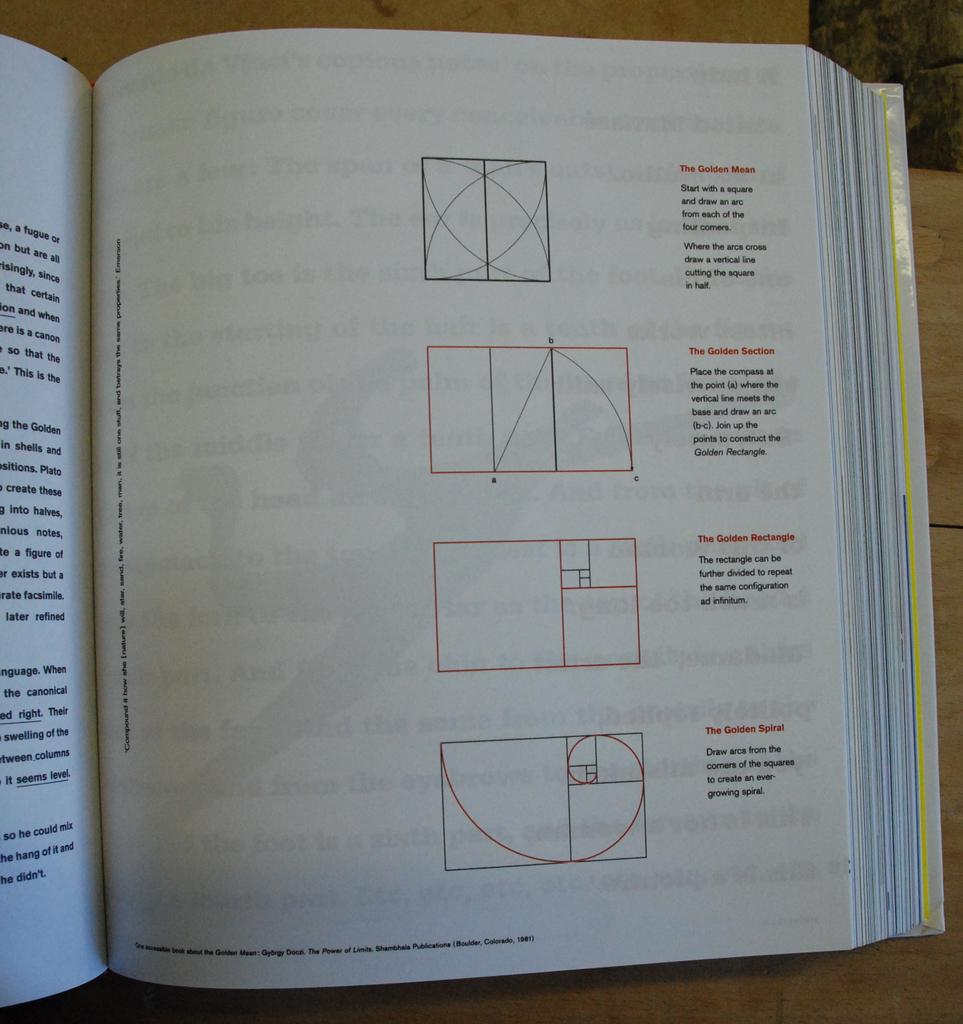<image>
Give a short and clear explanation of the subsequent image. A book showing several pictures with one called the golden mean at the top. 